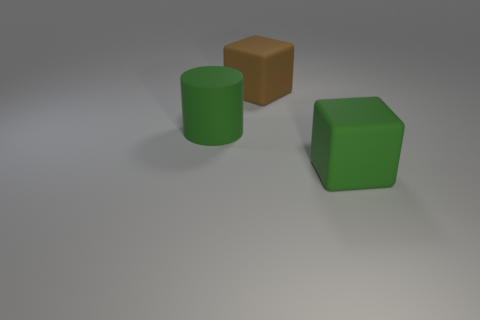There is a cube that is behind the large green matte object that is to the left of the brown rubber block; what is its color?
Provide a short and direct response. Brown. What is the shape of the green rubber object to the left of the matte block that is in front of the green object that is on the left side of the green matte cube?
Offer a terse response. Cylinder. There is a thing that is both behind the large green rubber cube and in front of the brown cube; what is its size?
Make the answer very short. Large. How many rubber objects are the same color as the large cylinder?
Make the answer very short. 1. There is a large object that is the same color as the matte cylinder; what is its material?
Give a very brief answer. Rubber. What material is the green cube?
Your answer should be very brief. Rubber. Does the cube that is behind the green cube have the same material as the green cylinder?
Offer a very short reply. Yes. What is the shape of the green object behind the large green matte block?
Provide a succinct answer. Cylinder. What material is the cylinder that is the same size as the brown thing?
Your response must be concise. Rubber. How many things are either rubber blocks in front of the large cylinder or blocks that are in front of the green matte cylinder?
Provide a succinct answer. 1. 